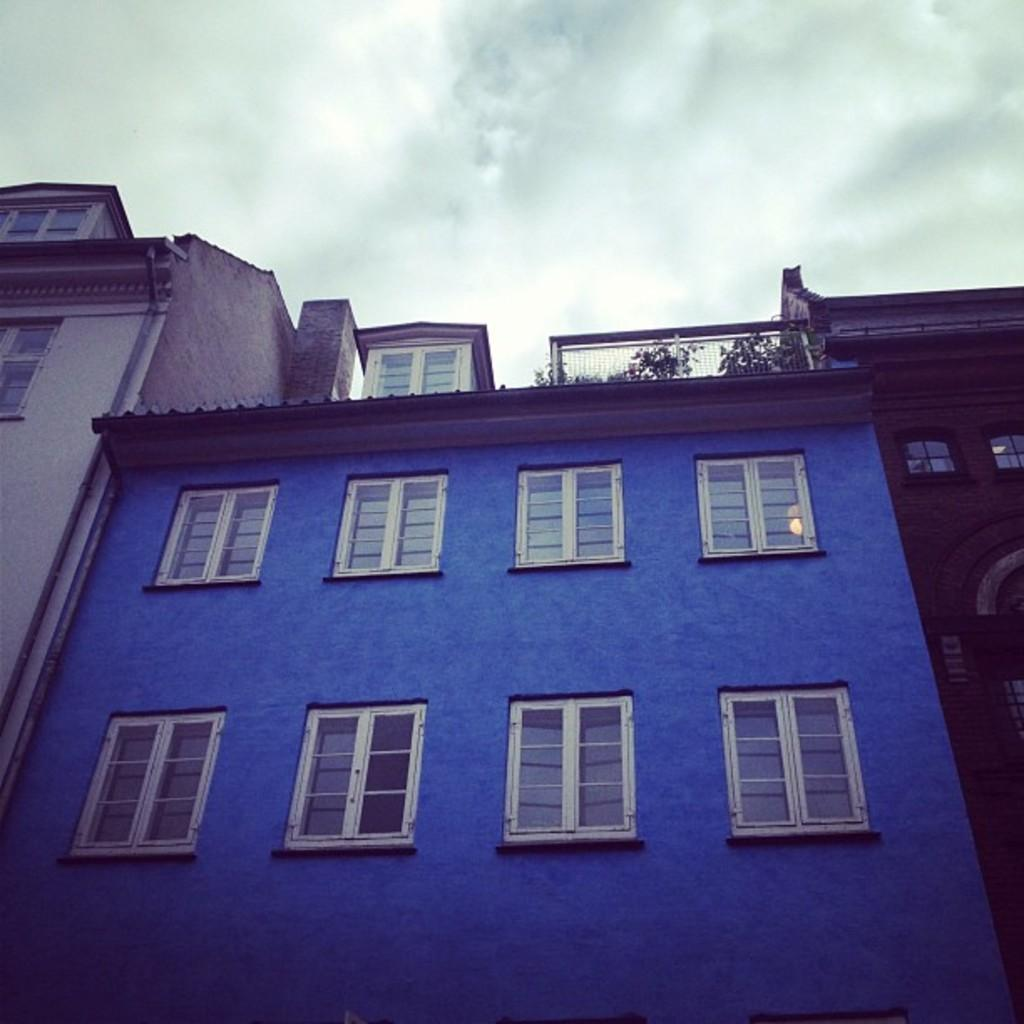What type of structures can be seen in the image? There are buildings in the image. What is depicted on the buildings? Planets are depicted on the buildings. What is visible at the top of the image? The sky is visible at the top of the image. What type of government is represented by the buildings in the image? There is no indication of a specific government in the image; it only shows buildings with planets depicted on them. How does the acoustics of the buildings affect the sound in the image? There is no information about the acoustics of the buildings or any sound in the image. 